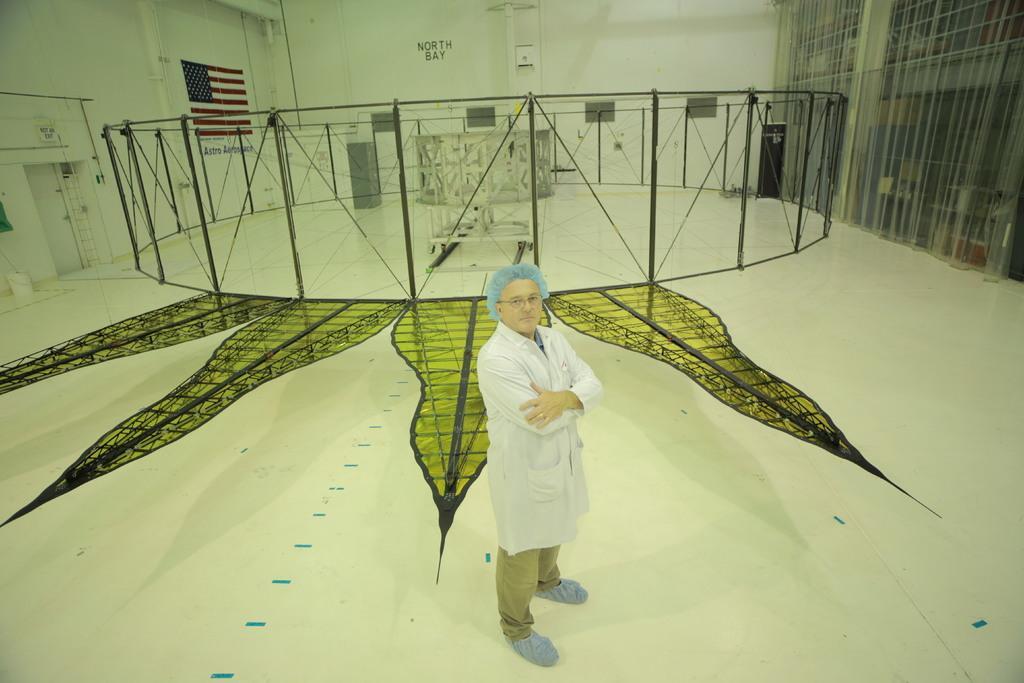Can you describe this image briefly? This is an inside view and it is looking like a hall. Here I can see a man wearing a white color jacket, standing on the floor and giving pose for the picture. In the background, I can see a net fencing, in the middle of that I can see a box which is placed on the floor. On the right and left side of the image I can see the walls along with the doors. On the left side a flag is attached to the wall. 